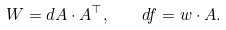<formula> <loc_0><loc_0><loc_500><loc_500>W = d A \cdot A ^ { \top } , \quad d f = w \cdot A .</formula> 